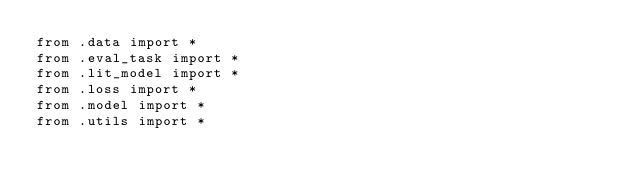Convert code to text. <code><loc_0><loc_0><loc_500><loc_500><_Python_>from .data import *
from .eval_task import *
from .lit_model import *
from .loss import *
from .model import *
from .utils import *</code> 